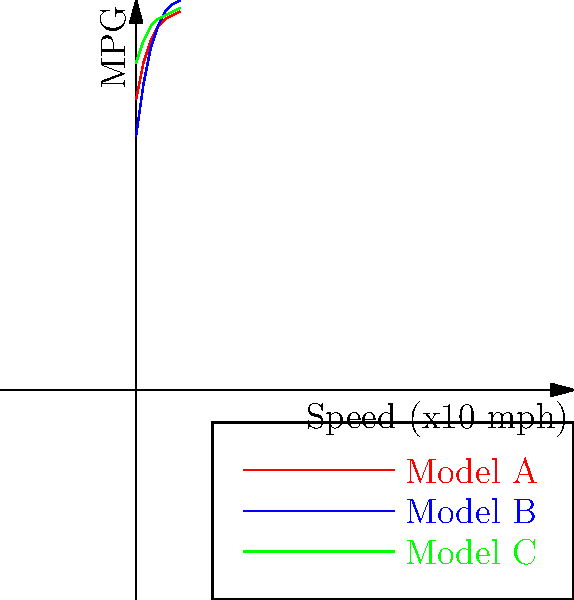Based on the fuel efficiency curves shown in the coordinate plane for three motorcycle models (A, B, and C), which model would you recommend for a beginner rider who primarily rides in city traffic at speeds between 20-30 mph? Explain your reasoning. To answer this question, we need to analyze the fuel efficiency curves for each model in the given speed range:

1. Convert the speed range to the x-axis scale:
   20-30 mph corresponds to x-values between 2 and 3 on the graph.

2. Examine each model's performance in this range:
   Model A (red): Efficiency increases from about 48 to 50 MPG
   Model B (blue): Efficiency increases from about 47 to 50 MPG
   Model C (green): Efficiency is relatively stable around 50-51 MPG

3. Consider the beginner rider's needs:
   - Consistent fuel efficiency is beneficial for predictable performance
   - Slightly higher MPG is advantageous for city riding with frequent stops

4. Evaluate the models:
   Model C offers the highest and most consistent fuel efficiency in the given speed range.
   Model A and B have similar efficiencies but are slightly lower than Model C.

5. Additional factors:
   Model C also performs well at lower speeds (below 20 mph), which is common in city traffic.

Given these considerations, Model C would be the most suitable recommendation for a beginner rider in city traffic conditions.
Answer: Model C 